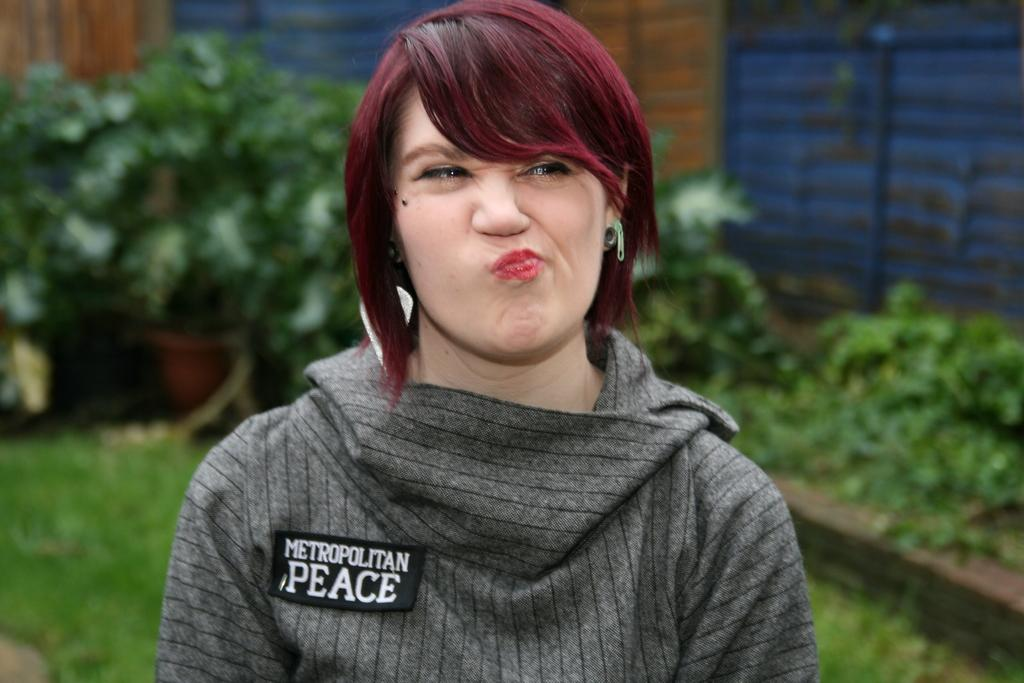What is the person in the image wearing? The person in the image is wearing a grey t-shirt. What can be seen in the background of the image? There is a building and trees in the background of the image. What type of vegetation is visible at the bottom of the image? There is grass visible at the bottom of the image. What type of pain is the person in the image experiencing? There is no indication in the image that the person is experiencing any pain. 